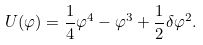<formula> <loc_0><loc_0><loc_500><loc_500>U ( \varphi ) = \frac { 1 } { 4 } \varphi ^ { 4 } - \varphi ^ { 3 } + \frac { 1 } { 2 } \delta \varphi ^ { 2 } .</formula> 